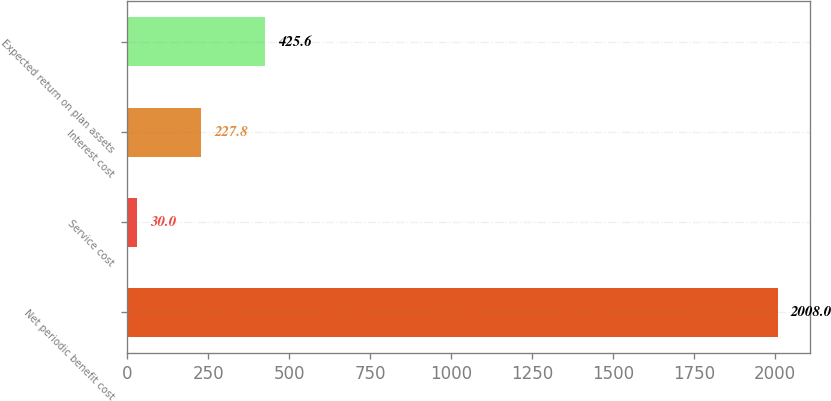<chart> <loc_0><loc_0><loc_500><loc_500><bar_chart><fcel>Net periodic benefit cost<fcel>Service cost<fcel>Interest cost<fcel>Expected return on plan assets<nl><fcel>2008<fcel>30<fcel>227.8<fcel>425.6<nl></chart> 